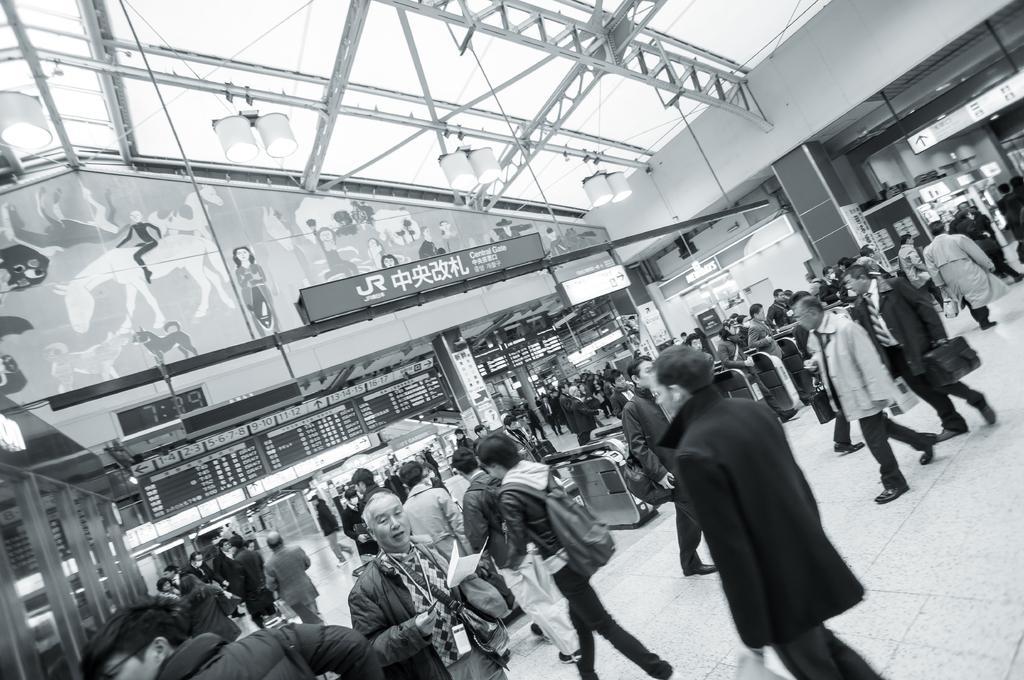Can you describe this image briefly? This is a black and white picture. In this picture, we see many people are holding the bags and they are walking. At the bottom, we see a man is wearing a bag and he is holding the papers in his hand. Behind him, we see many people are standing. On the right side, we see a board with some text written on it. Beside that, we see a pillar. In the background, we see the people are standing and we see the boards with some text written on it. On the left side, we see the poles. At the top, we see the roof of the building. 